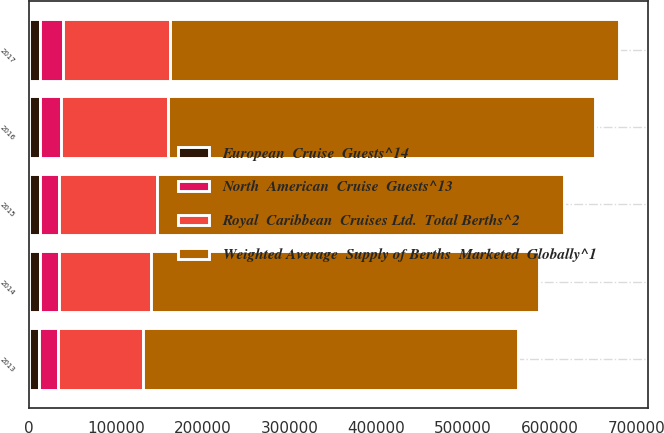Convert chart. <chart><loc_0><loc_0><loc_500><loc_500><stacked_bar_chart><ecel><fcel>2013<fcel>2014<fcel>2015<fcel>2016<fcel>2017<nl><fcel>Weighted Average  Supply of Berths  Marketed  Globally^1<fcel>432000<fcel>448000<fcel>469000<fcel>493000<fcel>517000<nl><fcel>Royal  Caribbean  Cruises Ltd.  Total Berths^2<fcel>98750<fcel>105750<fcel>112700<fcel>123270<fcel>124070<nl><fcel>North  American  Cruise  Guests^13<fcel>21343<fcel>22039<fcel>23000<fcel>24000<fcel>25800<nl><fcel>European  Cruise  Guests^14<fcel>11710<fcel>12269<fcel>12004<fcel>12274<fcel>12854<nl></chart> 